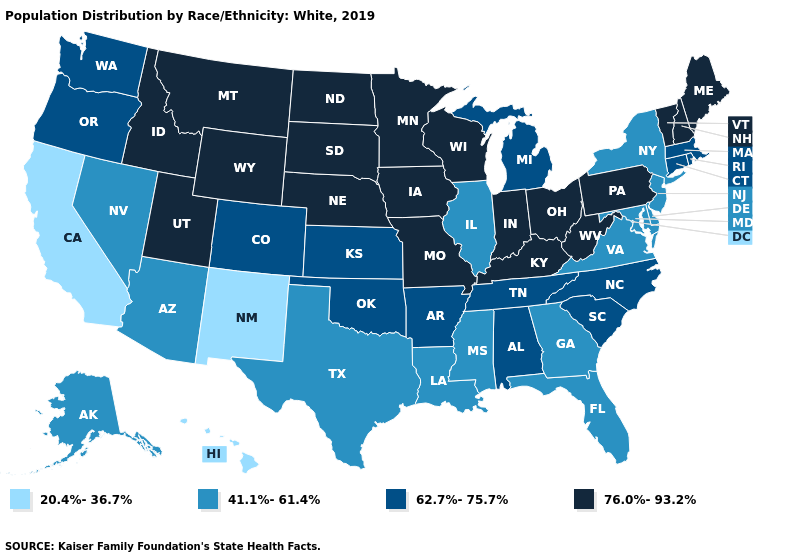Name the states that have a value in the range 41.1%-61.4%?
Quick response, please. Alaska, Arizona, Delaware, Florida, Georgia, Illinois, Louisiana, Maryland, Mississippi, Nevada, New Jersey, New York, Texas, Virginia. Among the states that border Missouri , does Illinois have the lowest value?
Be succinct. Yes. Does Kansas have a lower value than Maine?
Be succinct. Yes. What is the lowest value in states that border Utah?
Short answer required. 20.4%-36.7%. Among the states that border Missouri , which have the lowest value?
Concise answer only. Illinois. What is the highest value in states that border Michigan?
Be succinct. 76.0%-93.2%. Name the states that have a value in the range 20.4%-36.7%?
Short answer required. California, Hawaii, New Mexico. Name the states that have a value in the range 20.4%-36.7%?
Concise answer only. California, Hawaii, New Mexico. Is the legend a continuous bar?
Write a very short answer. No. Name the states that have a value in the range 41.1%-61.4%?
Short answer required. Alaska, Arizona, Delaware, Florida, Georgia, Illinois, Louisiana, Maryland, Mississippi, Nevada, New Jersey, New York, Texas, Virginia. What is the value of Montana?
Write a very short answer. 76.0%-93.2%. Which states have the lowest value in the Northeast?
Be succinct. New Jersey, New York. Which states have the lowest value in the West?
Be succinct. California, Hawaii, New Mexico. Does South Dakota have a higher value than Minnesota?
Short answer required. No. Is the legend a continuous bar?
Answer briefly. No. 